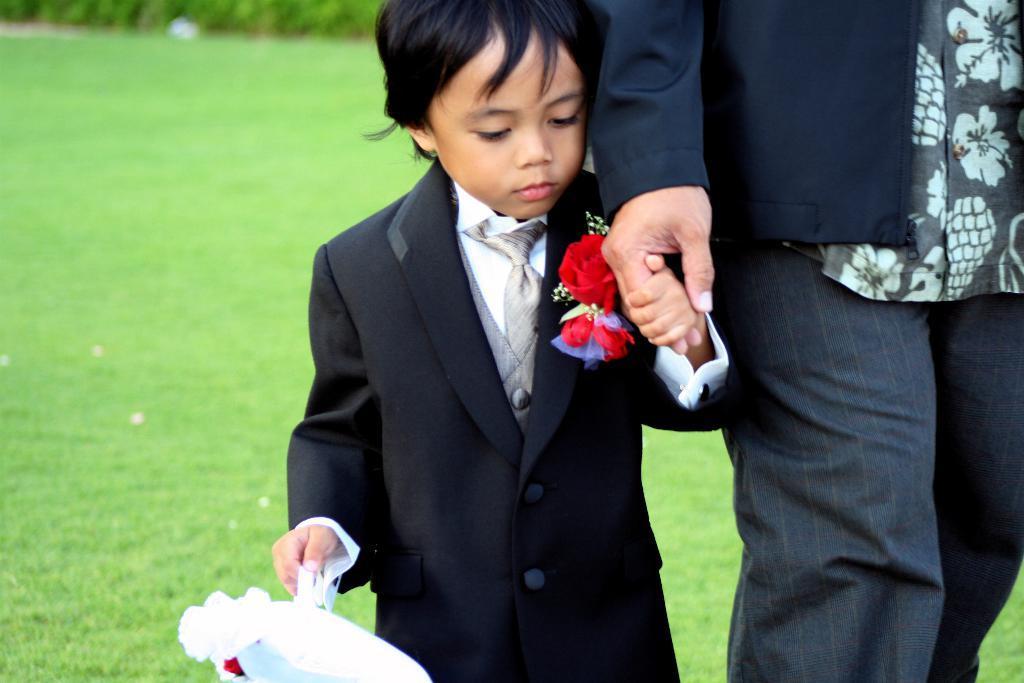Could you give a brief overview of what you see in this image? In this image we can see children holding human hands. And we can see the grass. 